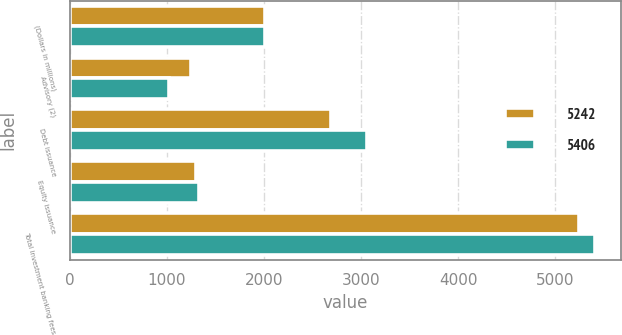<chart> <loc_0><loc_0><loc_500><loc_500><stacked_bar_chart><ecel><fcel>(Dollars in millions)<fcel>Advisory (2)<fcel>Debt issuance<fcel>Equity issuance<fcel>Total investment banking fees<nl><fcel>5242<fcel>2011<fcel>1246<fcel>2693<fcel>1303<fcel>5242<nl><fcel>5406<fcel>2010<fcel>1018<fcel>3059<fcel>1329<fcel>5406<nl></chart> 